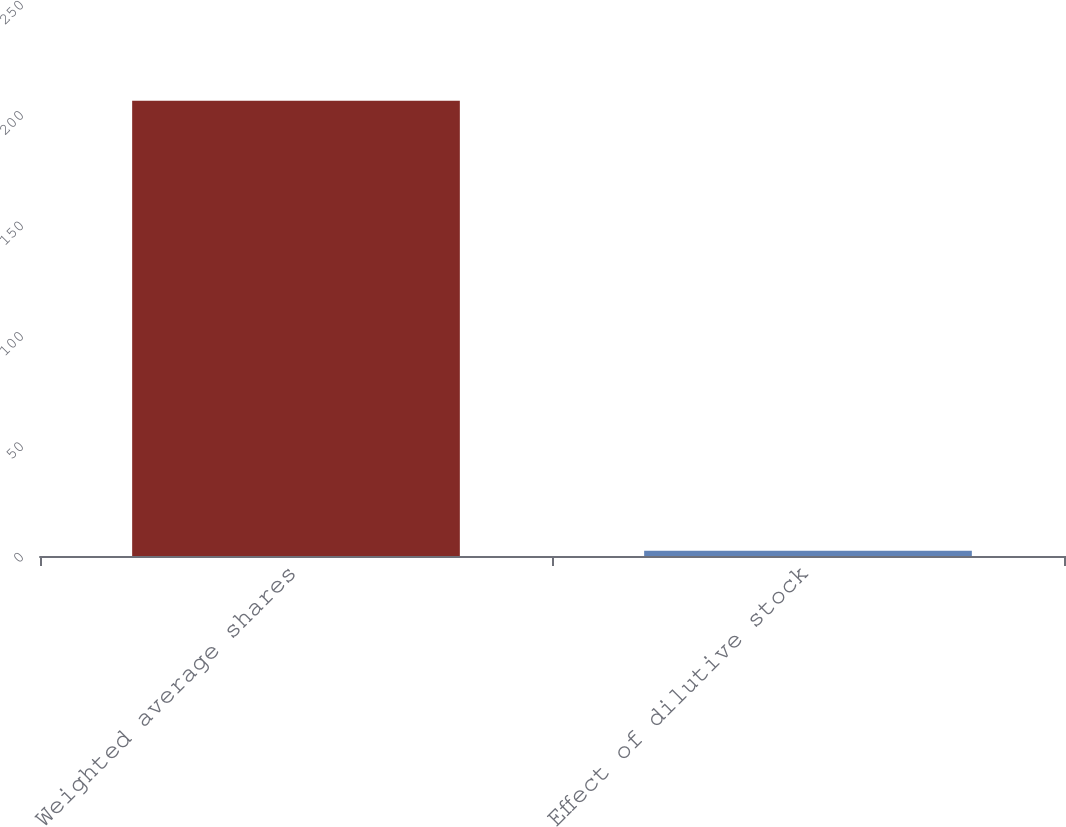Convert chart to OTSL. <chart><loc_0><loc_0><loc_500><loc_500><bar_chart><fcel>Weighted average shares<fcel>Effect of dilutive stock<nl><fcel>206.14<fcel>2.4<nl></chart> 